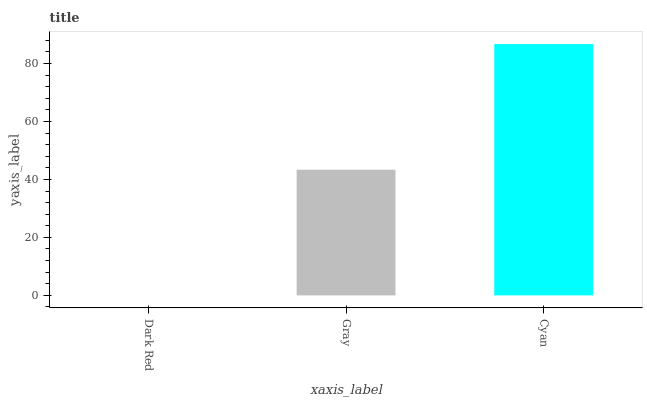Is Dark Red the minimum?
Answer yes or no. Yes. Is Cyan the maximum?
Answer yes or no. Yes. Is Gray the minimum?
Answer yes or no. No. Is Gray the maximum?
Answer yes or no. No. Is Gray greater than Dark Red?
Answer yes or no. Yes. Is Dark Red less than Gray?
Answer yes or no. Yes. Is Dark Red greater than Gray?
Answer yes or no. No. Is Gray less than Dark Red?
Answer yes or no. No. Is Gray the high median?
Answer yes or no. Yes. Is Gray the low median?
Answer yes or no. Yes. Is Dark Red the high median?
Answer yes or no. No. Is Dark Red the low median?
Answer yes or no. No. 